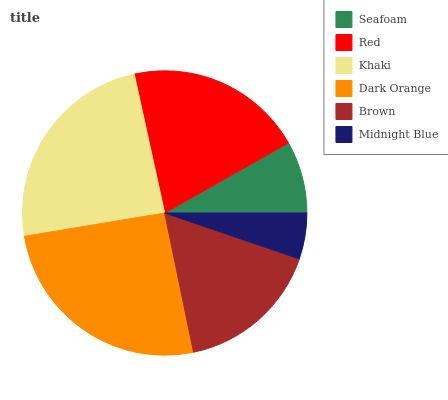Is Midnight Blue the minimum?
Answer yes or no. Yes. Is Dark Orange the maximum?
Answer yes or no. Yes. Is Red the minimum?
Answer yes or no. No. Is Red the maximum?
Answer yes or no. No. Is Red greater than Seafoam?
Answer yes or no. Yes. Is Seafoam less than Red?
Answer yes or no. Yes. Is Seafoam greater than Red?
Answer yes or no. No. Is Red less than Seafoam?
Answer yes or no. No. Is Red the high median?
Answer yes or no. Yes. Is Brown the low median?
Answer yes or no. Yes. Is Dark Orange the high median?
Answer yes or no. No. Is Red the low median?
Answer yes or no. No. 